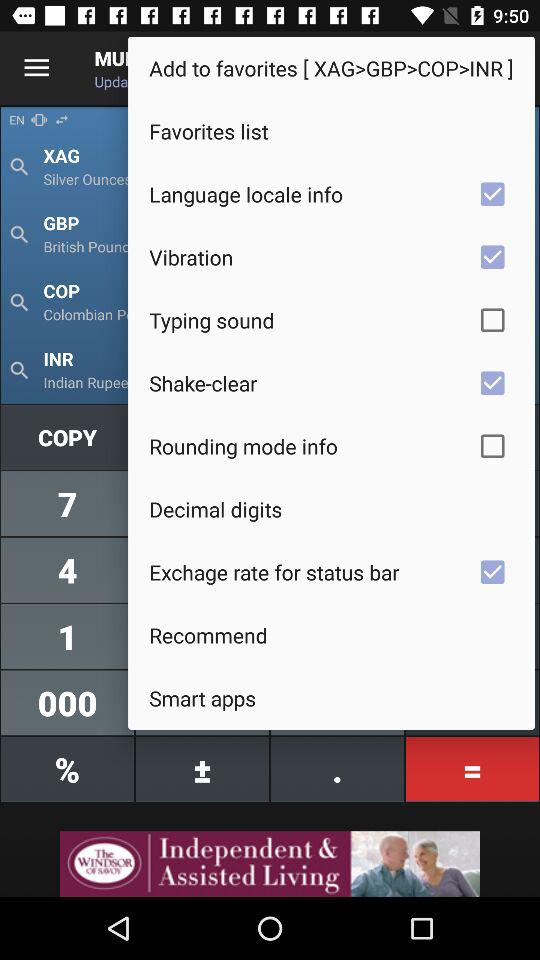What is the status of "Exchange rate for status bar"? The status is "on". 